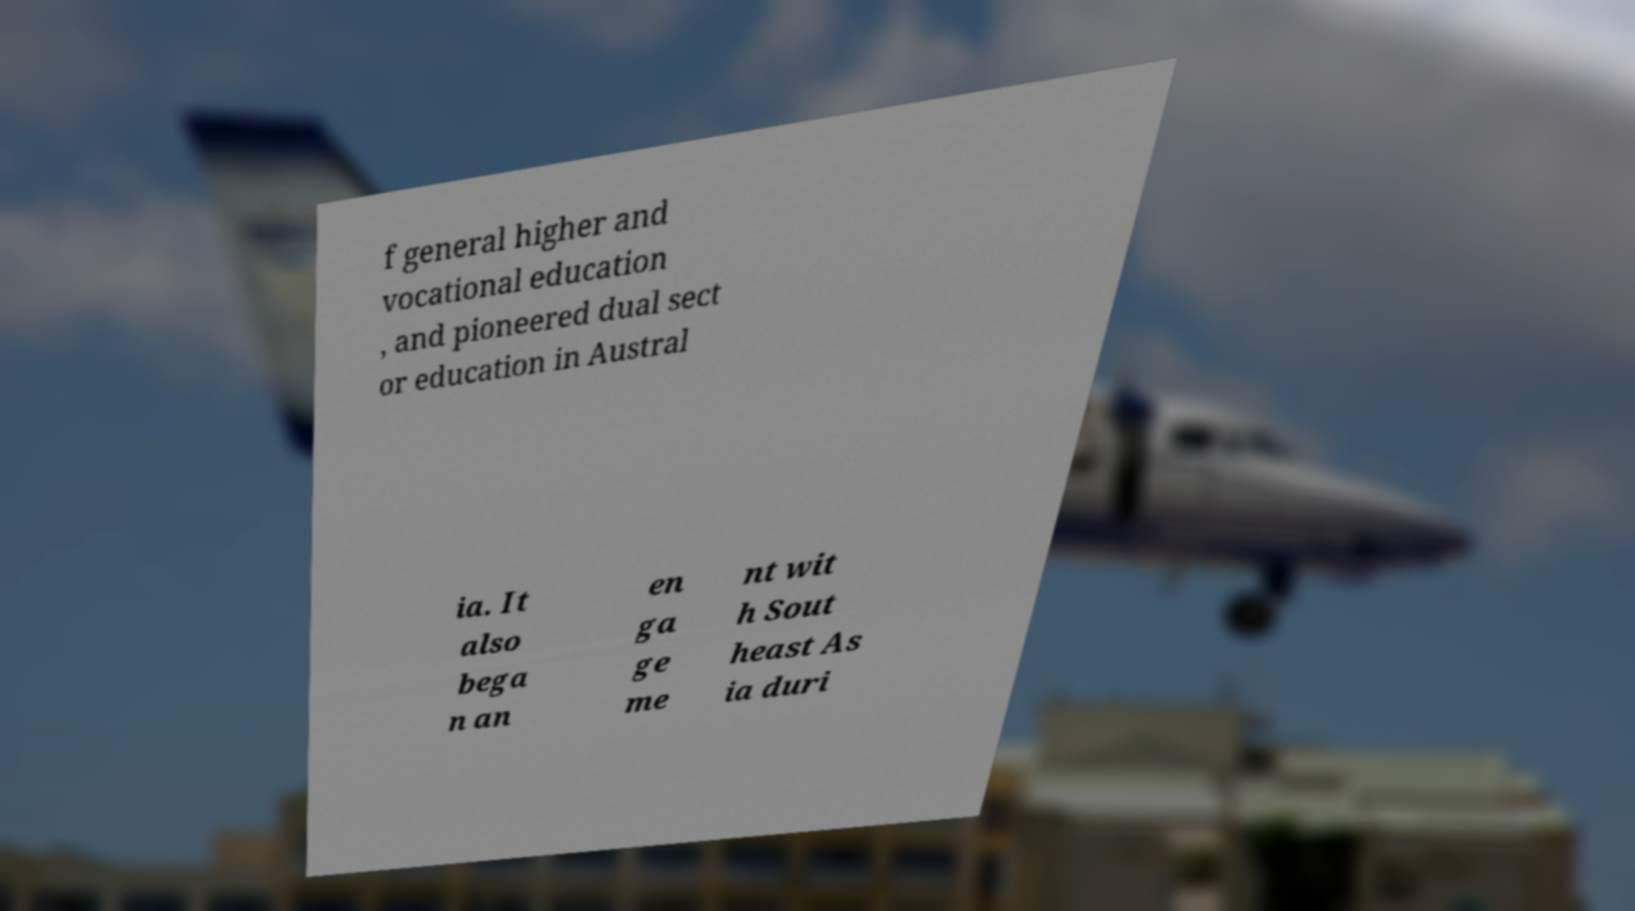Can you read and provide the text displayed in the image?This photo seems to have some interesting text. Can you extract and type it out for me? f general higher and vocational education , and pioneered dual sect or education in Austral ia. It also bega n an en ga ge me nt wit h Sout heast As ia duri 